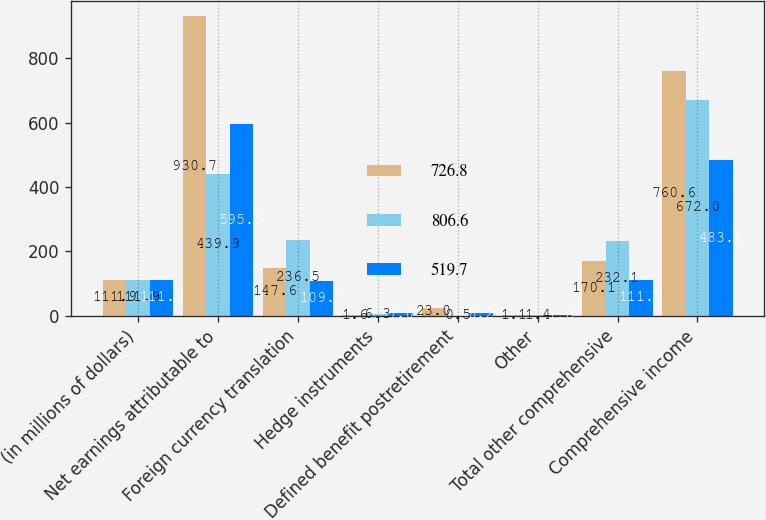Convert chart. <chart><loc_0><loc_0><loc_500><loc_500><stacked_bar_chart><ecel><fcel>(in millions of dollars)<fcel>Net earnings attributable to<fcel>Foreign currency translation<fcel>Hedge instruments<fcel>Defined benefit postretirement<fcel>Other<fcel>Total other comprehensive<fcel>Comprehensive income<nl><fcel>726.8<fcel>111.9<fcel>930.7<fcel>147.6<fcel>1.6<fcel>23<fcel>1.1<fcel>170.1<fcel>760.6<nl><fcel>806.6<fcel>111.9<fcel>439.9<fcel>236.5<fcel>6.3<fcel>0.5<fcel>1.4<fcel>232.1<fcel>672<nl><fcel>519.7<fcel>111.9<fcel>595<fcel>109.1<fcel>7<fcel>8.2<fcel>1.6<fcel>111.9<fcel>483.1<nl></chart> 